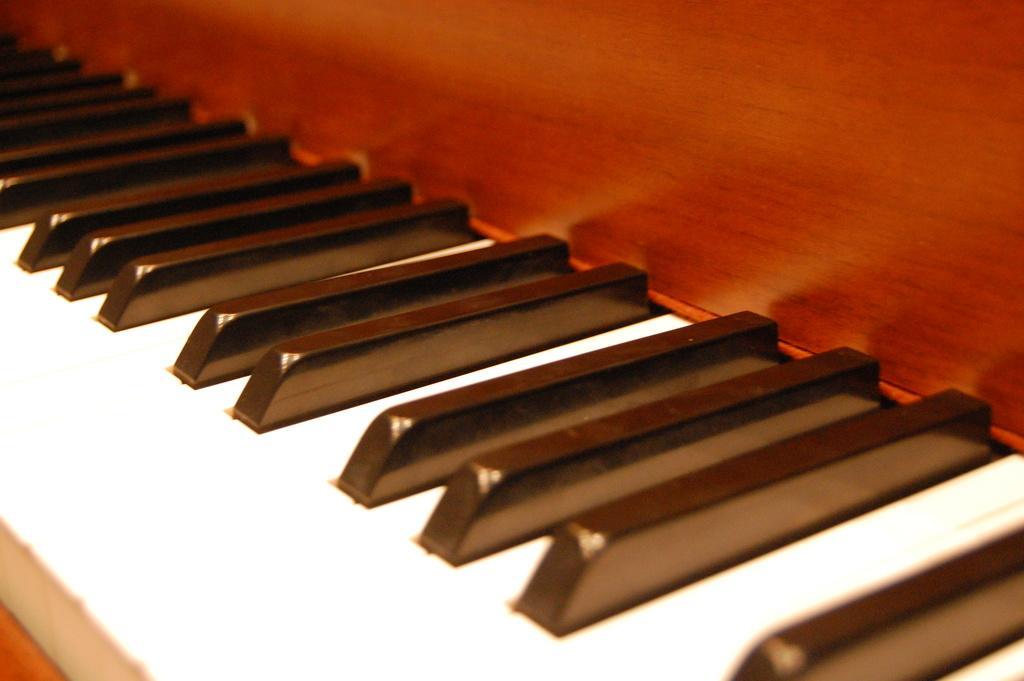Could you give a brief overview of what you see in this image? We can see piano keyboard. 